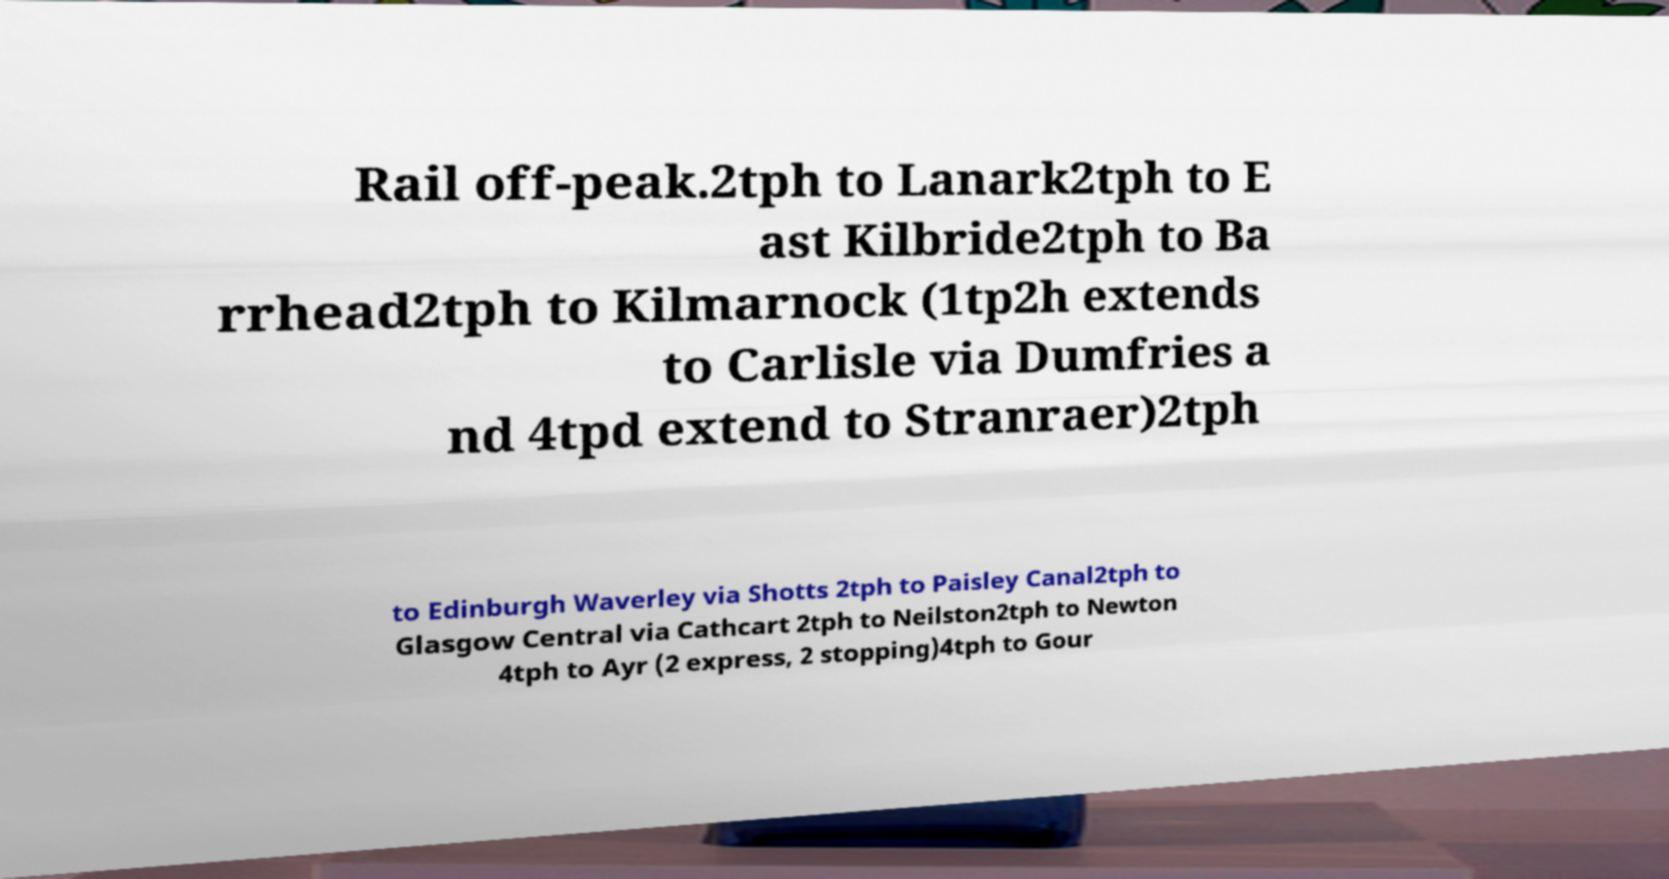What messages or text are displayed in this image? I need them in a readable, typed format. Rail off-peak.2tph to Lanark2tph to E ast Kilbride2tph to Ba rrhead2tph to Kilmarnock (1tp2h extends to Carlisle via Dumfries a nd 4tpd extend to Stranraer)2tph to Edinburgh Waverley via Shotts 2tph to Paisley Canal2tph to Glasgow Central via Cathcart 2tph to Neilston2tph to Newton 4tph to Ayr (2 express, 2 stopping)4tph to Gour 